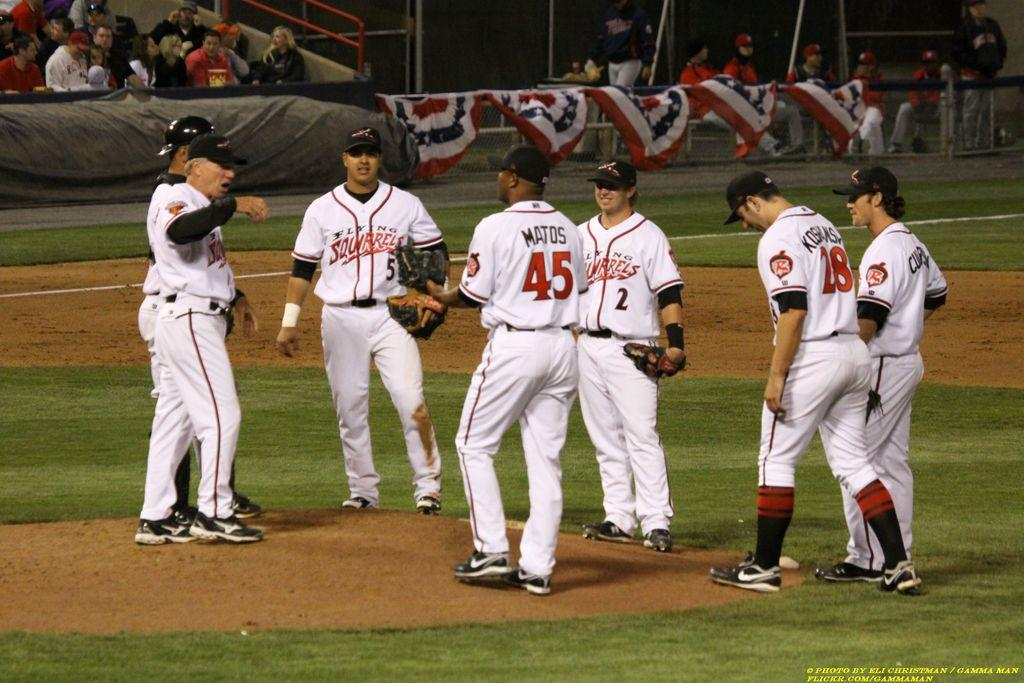<image>
Write a terse but informative summary of the picture. People wearing Flying Squirrels jerseys stand in a circle on a baseball field. 